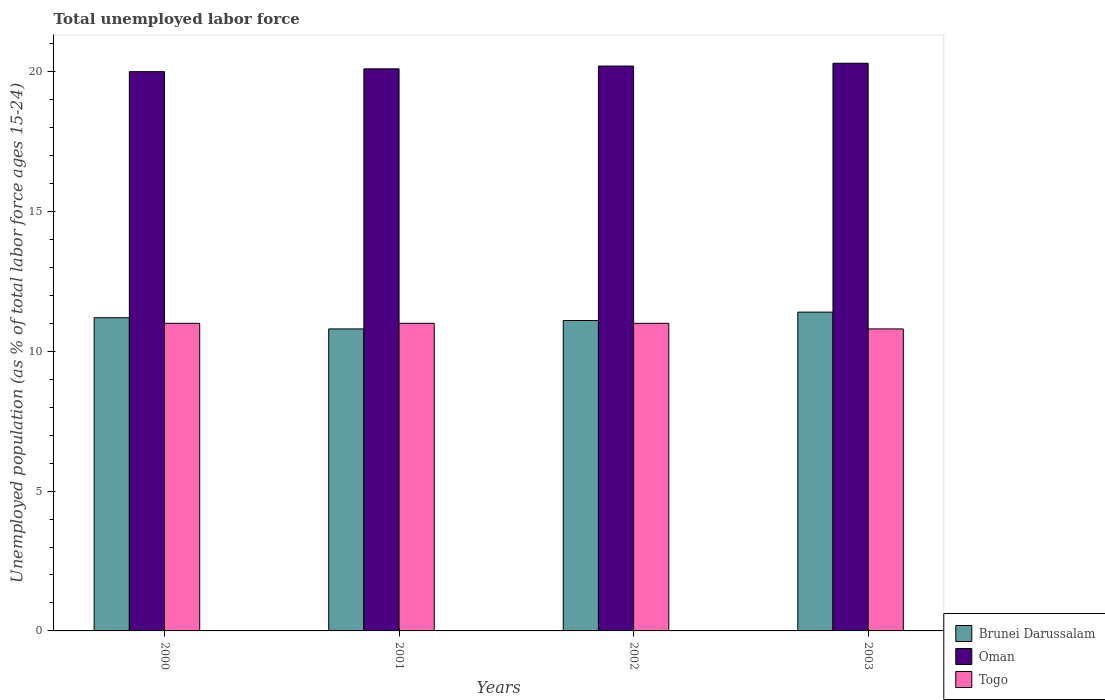Are the number of bars on each tick of the X-axis equal?
Ensure brevity in your answer.  Yes. How many bars are there on the 2nd tick from the right?
Ensure brevity in your answer.  3. What is the label of the 4th group of bars from the left?
Your answer should be compact. 2003. In how many cases, is the number of bars for a given year not equal to the number of legend labels?
Provide a short and direct response. 0. What is the percentage of unemployed population in in Oman in 2001?
Offer a terse response. 20.1. Across all years, what is the maximum percentage of unemployed population in in Oman?
Your answer should be very brief. 20.3. In which year was the percentage of unemployed population in in Oman minimum?
Make the answer very short. 2000. What is the total percentage of unemployed population in in Togo in the graph?
Provide a short and direct response. 43.8. What is the difference between the percentage of unemployed population in in Brunei Darussalam in 2002 and that in 2003?
Your answer should be compact. -0.3. What is the difference between the percentage of unemployed population in in Oman in 2001 and the percentage of unemployed population in in Togo in 2002?
Make the answer very short. 9.1. What is the average percentage of unemployed population in in Oman per year?
Keep it short and to the point. 20.15. In the year 2000, what is the difference between the percentage of unemployed population in in Brunei Darussalam and percentage of unemployed population in in Oman?
Keep it short and to the point. -8.8. In how many years, is the percentage of unemployed population in in Oman greater than 19 %?
Offer a very short reply. 4. What is the ratio of the percentage of unemployed population in in Brunei Darussalam in 2000 to that in 2001?
Provide a succinct answer. 1.04. What is the difference between the highest and the second highest percentage of unemployed population in in Brunei Darussalam?
Offer a very short reply. 0.2. What is the difference between the highest and the lowest percentage of unemployed population in in Oman?
Your answer should be compact. 0.3. In how many years, is the percentage of unemployed population in in Togo greater than the average percentage of unemployed population in in Togo taken over all years?
Your answer should be compact. 3. Is the sum of the percentage of unemployed population in in Brunei Darussalam in 2001 and 2002 greater than the maximum percentage of unemployed population in in Oman across all years?
Keep it short and to the point. Yes. What does the 2nd bar from the left in 2000 represents?
Offer a terse response. Oman. What does the 3rd bar from the right in 2000 represents?
Make the answer very short. Brunei Darussalam. Is it the case that in every year, the sum of the percentage of unemployed population in in Brunei Darussalam and percentage of unemployed population in in Oman is greater than the percentage of unemployed population in in Togo?
Give a very brief answer. Yes. How many bars are there?
Offer a very short reply. 12. How many years are there in the graph?
Make the answer very short. 4. How many legend labels are there?
Make the answer very short. 3. How are the legend labels stacked?
Provide a short and direct response. Vertical. What is the title of the graph?
Keep it short and to the point. Total unemployed labor force. Does "Slovenia" appear as one of the legend labels in the graph?
Offer a very short reply. No. What is the label or title of the Y-axis?
Your answer should be very brief. Unemployed population (as % of total labor force ages 15-24). What is the Unemployed population (as % of total labor force ages 15-24) in Brunei Darussalam in 2000?
Offer a very short reply. 11.2. What is the Unemployed population (as % of total labor force ages 15-24) of Brunei Darussalam in 2001?
Your response must be concise. 10.8. What is the Unemployed population (as % of total labor force ages 15-24) of Oman in 2001?
Your answer should be very brief. 20.1. What is the Unemployed population (as % of total labor force ages 15-24) in Brunei Darussalam in 2002?
Keep it short and to the point. 11.1. What is the Unemployed population (as % of total labor force ages 15-24) of Oman in 2002?
Your answer should be compact. 20.2. What is the Unemployed population (as % of total labor force ages 15-24) in Togo in 2002?
Make the answer very short. 11. What is the Unemployed population (as % of total labor force ages 15-24) in Brunei Darussalam in 2003?
Make the answer very short. 11.4. What is the Unemployed population (as % of total labor force ages 15-24) of Oman in 2003?
Your answer should be compact. 20.3. What is the Unemployed population (as % of total labor force ages 15-24) in Togo in 2003?
Provide a succinct answer. 10.8. Across all years, what is the maximum Unemployed population (as % of total labor force ages 15-24) in Brunei Darussalam?
Ensure brevity in your answer.  11.4. Across all years, what is the maximum Unemployed population (as % of total labor force ages 15-24) of Oman?
Make the answer very short. 20.3. Across all years, what is the minimum Unemployed population (as % of total labor force ages 15-24) in Brunei Darussalam?
Your answer should be compact. 10.8. Across all years, what is the minimum Unemployed population (as % of total labor force ages 15-24) in Togo?
Ensure brevity in your answer.  10.8. What is the total Unemployed population (as % of total labor force ages 15-24) in Brunei Darussalam in the graph?
Provide a short and direct response. 44.5. What is the total Unemployed population (as % of total labor force ages 15-24) in Oman in the graph?
Keep it short and to the point. 80.6. What is the total Unemployed population (as % of total labor force ages 15-24) of Togo in the graph?
Ensure brevity in your answer.  43.8. What is the difference between the Unemployed population (as % of total labor force ages 15-24) of Oman in 2000 and that in 2001?
Your answer should be very brief. -0.1. What is the difference between the Unemployed population (as % of total labor force ages 15-24) of Togo in 2000 and that in 2001?
Provide a succinct answer. 0. What is the difference between the Unemployed population (as % of total labor force ages 15-24) in Oman in 2000 and that in 2002?
Your answer should be compact. -0.2. What is the difference between the Unemployed population (as % of total labor force ages 15-24) of Togo in 2000 and that in 2002?
Your answer should be compact. 0. What is the difference between the Unemployed population (as % of total labor force ages 15-24) in Brunei Darussalam in 2000 and that in 2003?
Your answer should be compact. -0.2. What is the difference between the Unemployed population (as % of total labor force ages 15-24) in Brunei Darussalam in 2001 and that in 2002?
Provide a short and direct response. -0.3. What is the difference between the Unemployed population (as % of total labor force ages 15-24) of Togo in 2001 and that in 2002?
Your answer should be very brief. 0. What is the difference between the Unemployed population (as % of total labor force ages 15-24) of Brunei Darussalam in 2002 and that in 2003?
Offer a terse response. -0.3. What is the difference between the Unemployed population (as % of total labor force ages 15-24) of Brunei Darussalam in 2000 and the Unemployed population (as % of total labor force ages 15-24) of Togo in 2002?
Provide a short and direct response. 0.2. What is the difference between the Unemployed population (as % of total labor force ages 15-24) in Brunei Darussalam in 2000 and the Unemployed population (as % of total labor force ages 15-24) in Oman in 2003?
Your response must be concise. -9.1. What is the difference between the Unemployed population (as % of total labor force ages 15-24) in Brunei Darussalam in 2000 and the Unemployed population (as % of total labor force ages 15-24) in Togo in 2003?
Make the answer very short. 0.4. What is the difference between the Unemployed population (as % of total labor force ages 15-24) in Oman in 2000 and the Unemployed population (as % of total labor force ages 15-24) in Togo in 2003?
Keep it short and to the point. 9.2. What is the difference between the Unemployed population (as % of total labor force ages 15-24) in Brunei Darussalam in 2001 and the Unemployed population (as % of total labor force ages 15-24) in Oman in 2002?
Provide a succinct answer. -9.4. What is the difference between the Unemployed population (as % of total labor force ages 15-24) of Brunei Darussalam in 2001 and the Unemployed population (as % of total labor force ages 15-24) of Togo in 2002?
Make the answer very short. -0.2. What is the difference between the Unemployed population (as % of total labor force ages 15-24) in Oman in 2001 and the Unemployed population (as % of total labor force ages 15-24) in Togo in 2002?
Your response must be concise. 9.1. What is the difference between the Unemployed population (as % of total labor force ages 15-24) in Brunei Darussalam in 2001 and the Unemployed population (as % of total labor force ages 15-24) in Togo in 2003?
Ensure brevity in your answer.  0. What is the difference between the Unemployed population (as % of total labor force ages 15-24) in Oman in 2001 and the Unemployed population (as % of total labor force ages 15-24) in Togo in 2003?
Make the answer very short. 9.3. What is the difference between the Unemployed population (as % of total labor force ages 15-24) of Brunei Darussalam in 2002 and the Unemployed population (as % of total labor force ages 15-24) of Oman in 2003?
Your answer should be compact. -9.2. What is the difference between the Unemployed population (as % of total labor force ages 15-24) of Oman in 2002 and the Unemployed population (as % of total labor force ages 15-24) of Togo in 2003?
Ensure brevity in your answer.  9.4. What is the average Unemployed population (as % of total labor force ages 15-24) of Brunei Darussalam per year?
Your answer should be very brief. 11.12. What is the average Unemployed population (as % of total labor force ages 15-24) of Oman per year?
Make the answer very short. 20.15. What is the average Unemployed population (as % of total labor force ages 15-24) of Togo per year?
Make the answer very short. 10.95. In the year 2000, what is the difference between the Unemployed population (as % of total labor force ages 15-24) of Brunei Darussalam and Unemployed population (as % of total labor force ages 15-24) of Togo?
Give a very brief answer. 0.2. In the year 2002, what is the difference between the Unemployed population (as % of total labor force ages 15-24) in Oman and Unemployed population (as % of total labor force ages 15-24) in Togo?
Your response must be concise. 9.2. In the year 2003, what is the difference between the Unemployed population (as % of total labor force ages 15-24) in Brunei Darussalam and Unemployed population (as % of total labor force ages 15-24) in Oman?
Your answer should be very brief. -8.9. In the year 2003, what is the difference between the Unemployed population (as % of total labor force ages 15-24) of Brunei Darussalam and Unemployed population (as % of total labor force ages 15-24) of Togo?
Offer a very short reply. 0.6. What is the ratio of the Unemployed population (as % of total labor force ages 15-24) in Oman in 2000 to that in 2001?
Keep it short and to the point. 0.99. What is the ratio of the Unemployed population (as % of total labor force ages 15-24) of Togo in 2000 to that in 2001?
Offer a very short reply. 1. What is the ratio of the Unemployed population (as % of total labor force ages 15-24) of Brunei Darussalam in 2000 to that in 2002?
Provide a short and direct response. 1.01. What is the ratio of the Unemployed population (as % of total labor force ages 15-24) in Brunei Darussalam in 2000 to that in 2003?
Ensure brevity in your answer.  0.98. What is the ratio of the Unemployed population (as % of total labor force ages 15-24) of Oman in 2000 to that in 2003?
Keep it short and to the point. 0.99. What is the ratio of the Unemployed population (as % of total labor force ages 15-24) in Togo in 2000 to that in 2003?
Your answer should be compact. 1.02. What is the ratio of the Unemployed population (as % of total labor force ages 15-24) in Oman in 2001 to that in 2002?
Provide a short and direct response. 0.99. What is the ratio of the Unemployed population (as % of total labor force ages 15-24) in Togo in 2001 to that in 2002?
Offer a very short reply. 1. What is the ratio of the Unemployed population (as % of total labor force ages 15-24) of Brunei Darussalam in 2001 to that in 2003?
Offer a terse response. 0.95. What is the ratio of the Unemployed population (as % of total labor force ages 15-24) of Oman in 2001 to that in 2003?
Your answer should be very brief. 0.99. What is the ratio of the Unemployed population (as % of total labor force ages 15-24) of Togo in 2001 to that in 2003?
Ensure brevity in your answer.  1.02. What is the ratio of the Unemployed population (as % of total labor force ages 15-24) in Brunei Darussalam in 2002 to that in 2003?
Offer a very short reply. 0.97. What is the ratio of the Unemployed population (as % of total labor force ages 15-24) of Togo in 2002 to that in 2003?
Provide a short and direct response. 1.02. What is the difference between the highest and the lowest Unemployed population (as % of total labor force ages 15-24) in Oman?
Keep it short and to the point. 0.3. 